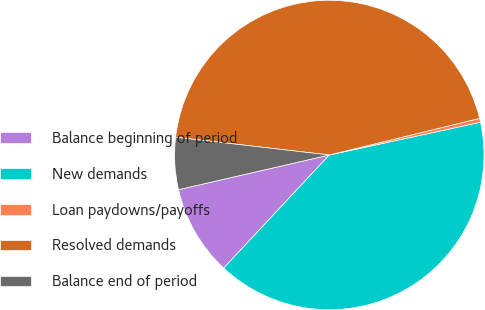Convert chart. <chart><loc_0><loc_0><loc_500><loc_500><pie_chart><fcel>Balance beginning of period<fcel>New demands<fcel>Loan paydowns/payoffs<fcel>Resolved demands<fcel>Balance end of period<nl><fcel>9.44%<fcel>40.35%<fcel>0.41%<fcel>44.36%<fcel>5.43%<nl></chart> 